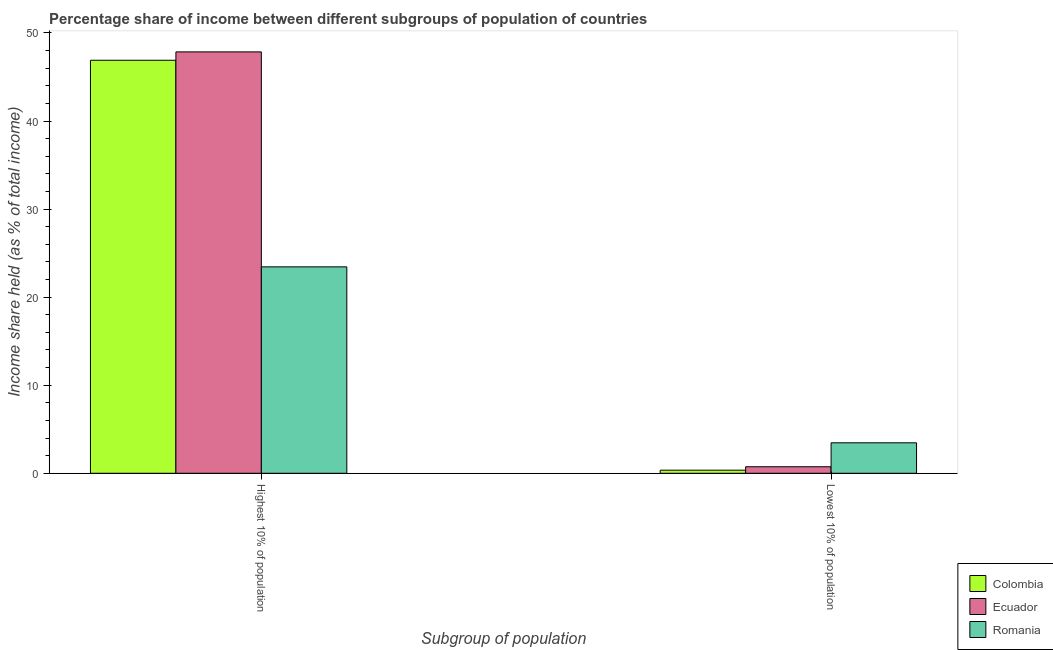How many bars are there on the 2nd tick from the left?
Offer a very short reply. 3. What is the label of the 1st group of bars from the left?
Provide a succinct answer. Highest 10% of population. What is the income share held by highest 10% of the population in Romania?
Your answer should be compact. 23.44. Across all countries, what is the maximum income share held by lowest 10% of the population?
Your answer should be compact. 3.46. Across all countries, what is the minimum income share held by highest 10% of the population?
Offer a very short reply. 23.44. In which country was the income share held by highest 10% of the population maximum?
Provide a short and direct response. Ecuador. In which country was the income share held by highest 10% of the population minimum?
Give a very brief answer. Romania. What is the total income share held by highest 10% of the population in the graph?
Ensure brevity in your answer.  118.19. What is the difference between the income share held by highest 10% of the population in Colombia and that in Ecuador?
Provide a succinct answer. -0.95. What is the difference between the income share held by highest 10% of the population in Ecuador and the income share held by lowest 10% of the population in Colombia?
Give a very brief answer. 47.5. What is the average income share held by highest 10% of the population per country?
Give a very brief answer. 39.4. What is the difference between the income share held by highest 10% of the population and income share held by lowest 10% of the population in Colombia?
Your answer should be very brief. 46.55. What is the ratio of the income share held by highest 10% of the population in Colombia to that in Romania?
Your answer should be compact. 2. What does the 2nd bar from the left in Highest 10% of population represents?
Keep it short and to the point. Ecuador. What does the 3rd bar from the right in Highest 10% of population represents?
Keep it short and to the point. Colombia. Are all the bars in the graph horizontal?
Provide a succinct answer. No. How many countries are there in the graph?
Offer a very short reply. 3. What is the difference between two consecutive major ticks on the Y-axis?
Offer a terse response. 10. Does the graph contain any zero values?
Your response must be concise. No. Where does the legend appear in the graph?
Offer a very short reply. Bottom right. What is the title of the graph?
Make the answer very short. Percentage share of income between different subgroups of population of countries. Does "Arab World" appear as one of the legend labels in the graph?
Give a very brief answer. No. What is the label or title of the X-axis?
Keep it short and to the point. Subgroup of population. What is the label or title of the Y-axis?
Your answer should be very brief. Income share held (as % of total income). What is the Income share held (as % of total income) of Colombia in Highest 10% of population?
Ensure brevity in your answer.  46.9. What is the Income share held (as % of total income) of Ecuador in Highest 10% of population?
Offer a terse response. 47.85. What is the Income share held (as % of total income) in Romania in Highest 10% of population?
Offer a terse response. 23.44. What is the Income share held (as % of total income) of Ecuador in Lowest 10% of population?
Provide a succinct answer. 0.74. What is the Income share held (as % of total income) in Romania in Lowest 10% of population?
Provide a short and direct response. 3.46. Across all Subgroup of population, what is the maximum Income share held (as % of total income) of Colombia?
Your answer should be compact. 46.9. Across all Subgroup of population, what is the maximum Income share held (as % of total income) in Ecuador?
Offer a very short reply. 47.85. Across all Subgroup of population, what is the maximum Income share held (as % of total income) of Romania?
Your answer should be compact. 23.44. Across all Subgroup of population, what is the minimum Income share held (as % of total income) of Colombia?
Ensure brevity in your answer.  0.35. Across all Subgroup of population, what is the minimum Income share held (as % of total income) of Ecuador?
Make the answer very short. 0.74. Across all Subgroup of population, what is the minimum Income share held (as % of total income) of Romania?
Your response must be concise. 3.46. What is the total Income share held (as % of total income) of Colombia in the graph?
Make the answer very short. 47.25. What is the total Income share held (as % of total income) in Ecuador in the graph?
Give a very brief answer. 48.59. What is the total Income share held (as % of total income) of Romania in the graph?
Your response must be concise. 26.9. What is the difference between the Income share held (as % of total income) in Colombia in Highest 10% of population and that in Lowest 10% of population?
Offer a very short reply. 46.55. What is the difference between the Income share held (as % of total income) of Ecuador in Highest 10% of population and that in Lowest 10% of population?
Provide a succinct answer. 47.11. What is the difference between the Income share held (as % of total income) of Romania in Highest 10% of population and that in Lowest 10% of population?
Give a very brief answer. 19.98. What is the difference between the Income share held (as % of total income) of Colombia in Highest 10% of population and the Income share held (as % of total income) of Ecuador in Lowest 10% of population?
Provide a succinct answer. 46.16. What is the difference between the Income share held (as % of total income) of Colombia in Highest 10% of population and the Income share held (as % of total income) of Romania in Lowest 10% of population?
Ensure brevity in your answer.  43.44. What is the difference between the Income share held (as % of total income) of Ecuador in Highest 10% of population and the Income share held (as % of total income) of Romania in Lowest 10% of population?
Your answer should be compact. 44.39. What is the average Income share held (as % of total income) in Colombia per Subgroup of population?
Provide a succinct answer. 23.62. What is the average Income share held (as % of total income) of Ecuador per Subgroup of population?
Provide a succinct answer. 24.3. What is the average Income share held (as % of total income) of Romania per Subgroup of population?
Provide a succinct answer. 13.45. What is the difference between the Income share held (as % of total income) in Colombia and Income share held (as % of total income) in Ecuador in Highest 10% of population?
Give a very brief answer. -0.95. What is the difference between the Income share held (as % of total income) in Colombia and Income share held (as % of total income) in Romania in Highest 10% of population?
Provide a short and direct response. 23.46. What is the difference between the Income share held (as % of total income) in Ecuador and Income share held (as % of total income) in Romania in Highest 10% of population?
Ensure brevity in your answer.  24.41. What is the difference between the Income share held (as % of total income) of Colombia and Income share held (as % of total income) of Ecuador in Lowest 10% of population?
Provide a succinct answer. -0.39. What is the difference between the Income share held (as % of total income) in Colombia and Income share held (as % of total income) in Romania in Lowest 10% of population?
Your answer should be compact. -3.11. What is the difference between the Income share held (as % of total income) of Ecuador and Income share held (as % of total income) of Romania in Lowest 10% of population?
Give a very brief answer. -2.72. What is the ratio of the Income share held (as % of total income) of Colombia in Highest 10% of population to that in Lowest 10% of population?
Keep it short and to the point. 134. What is the ratio of the Income share held (as % of total income) in Ecuador in Highest 10% of population to that in Lowest 10% of population?
Keep it short and to the point. 64.66. What is the ratio of the Income share held (as % of total income) of Romania in Highest 10% of population to that in Lowest 10% of population?
Your answer should be very brief. 6.77. What is the difference between the highest and the second highest Income share held (as % of total income) in Colombia?
Ensure brevity in your answer.  46.55. What is the difference between the highest and the second highest Income share held (as % of total income) in Ecuador?
Your answer should be very brief. 47.11. What is the difference between the highest and the second highest Income share held (as % of total income) in Romania?
Ensure brevity in your answer.  19.98. What is the difference between the highest and the lowest Income share held (as % of total income) of Colombia?
Your answer should be compact. 46.55. What is the difference between the highest and the lowest Income share held (as % of total income) of Ecuador?
Your response must be concise. 47.11. What is the difference between the highest and the lowest Income share held (as % of total income) in Romania?
Your answer should be compact. 19.98. 